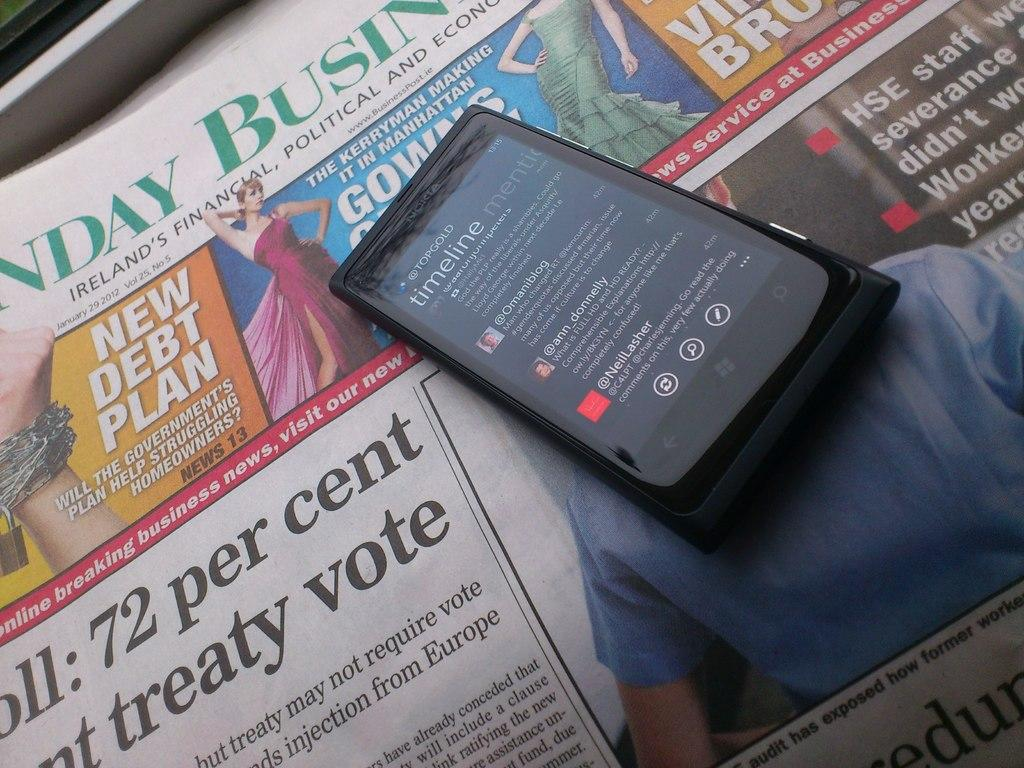Provide a one-sentence caption for the provided image. A newspaper that says 72 per cent and treaty vote on the front with a cell phone sitting on top of it that says timeline on the screen. 